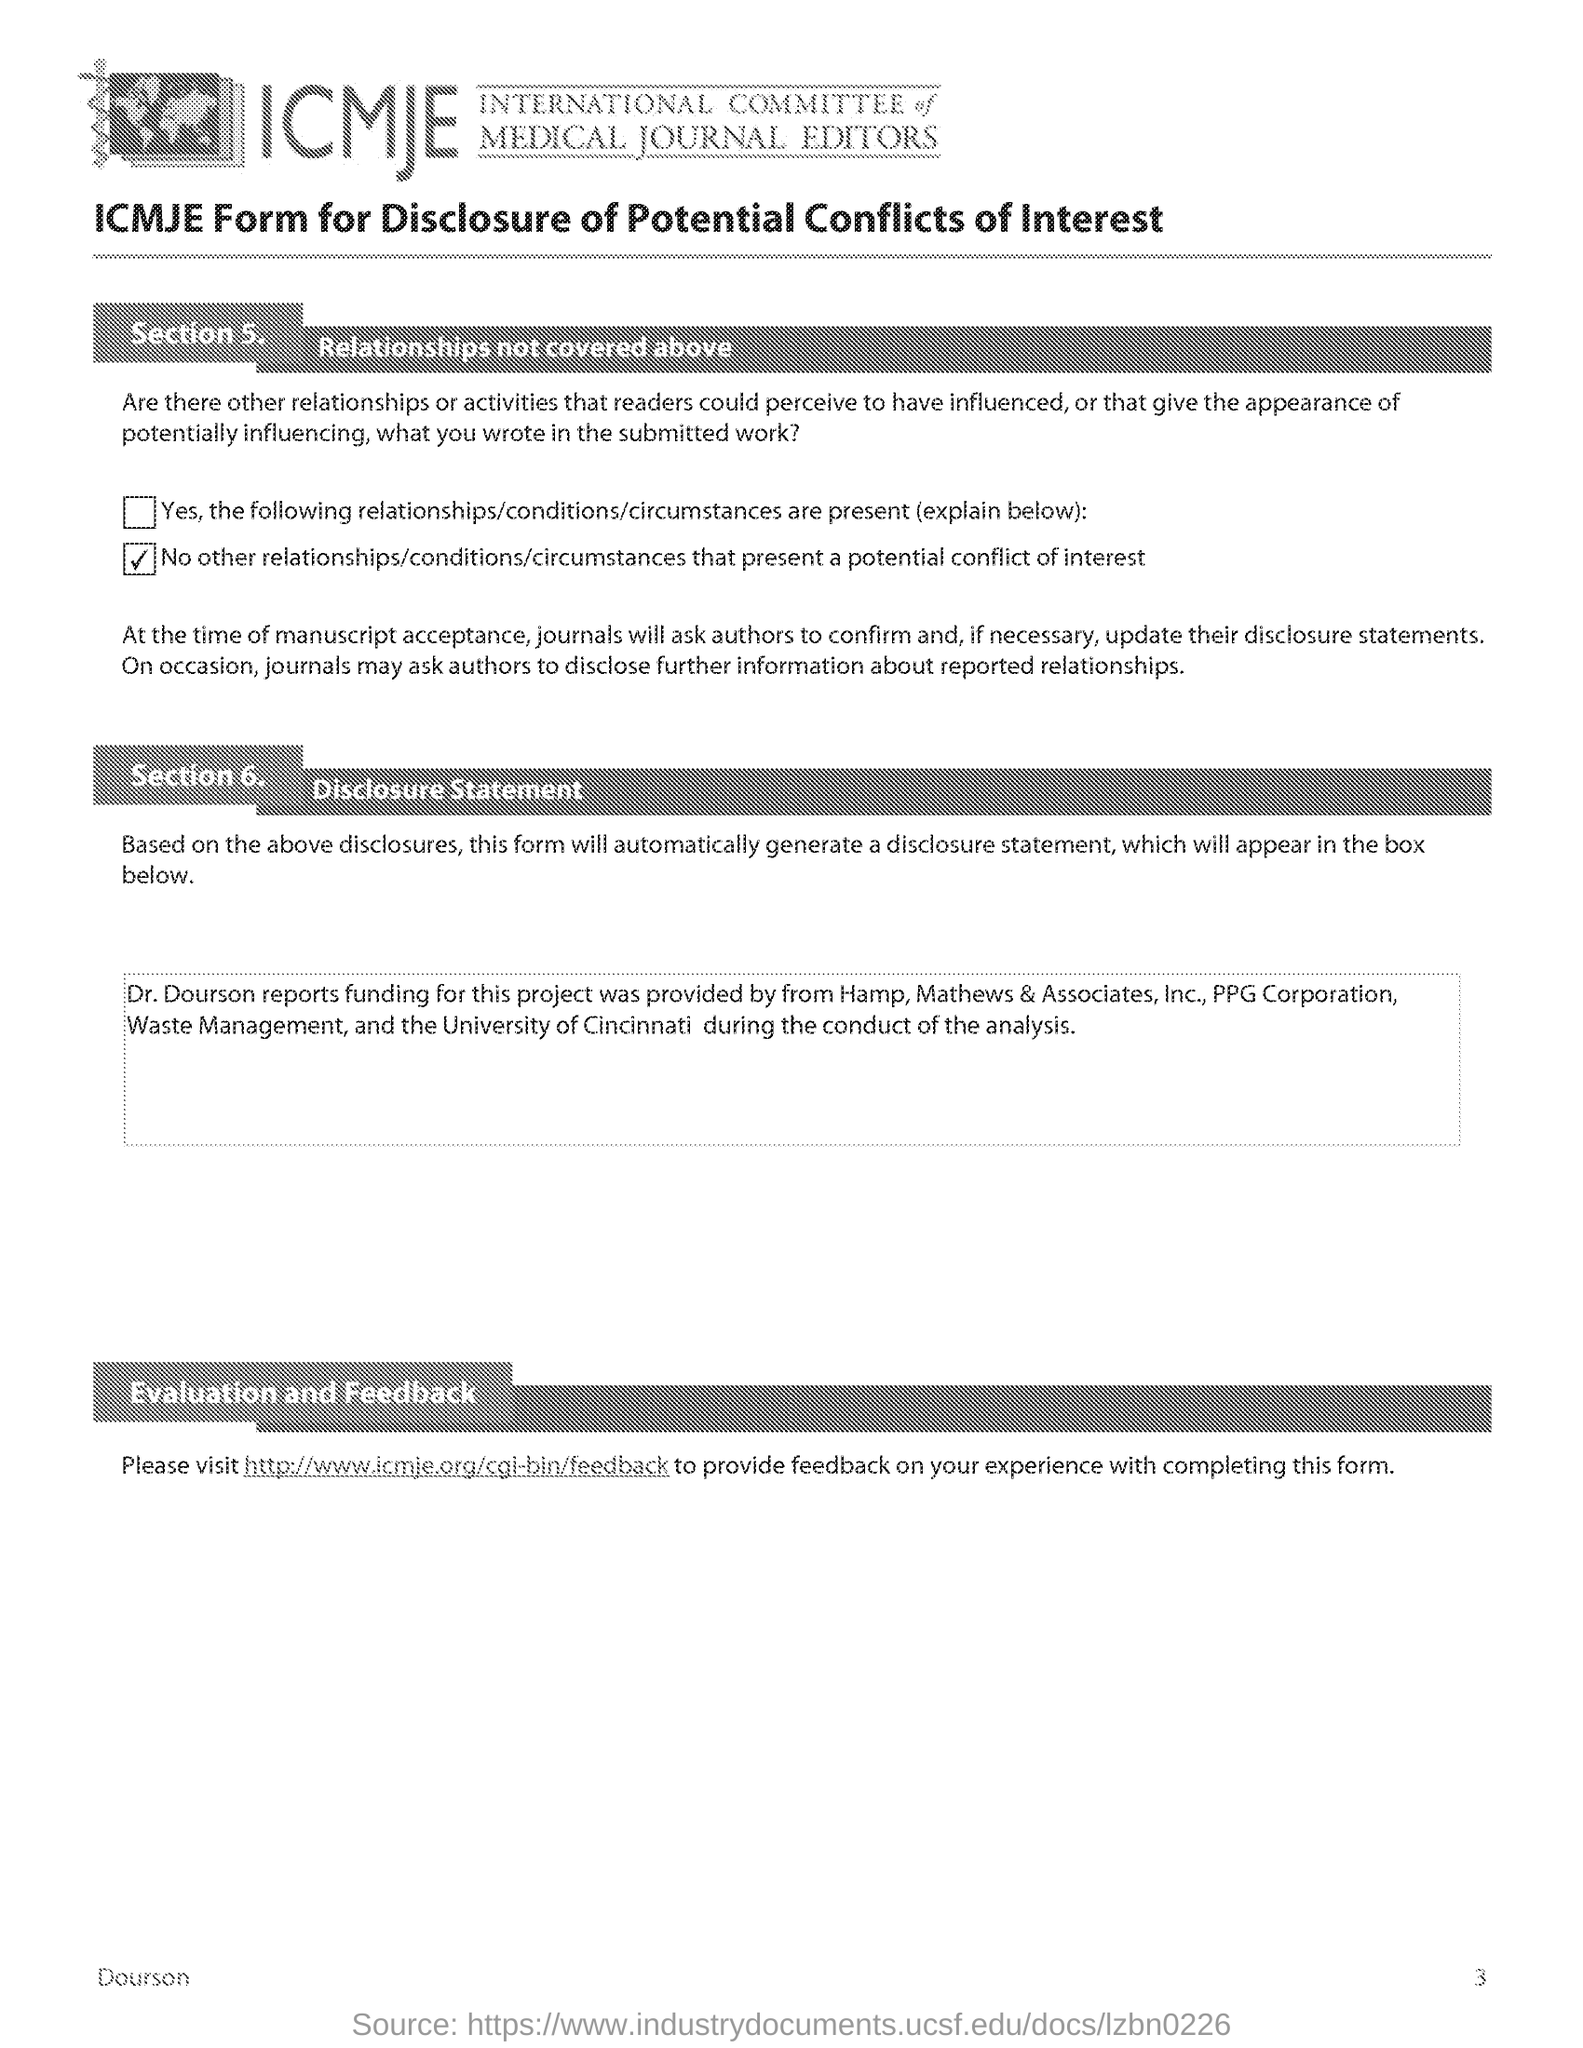Draw attention to some important aspects in this diagram. ICMJE stands for the International Committee of Medical Journal Editors, an organization that sets standards for the evaluation of scientific quality and integrity of medical journals. Section 5 covers relationships that are not covered in the previous sections. 